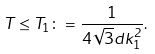Convert formula to latex. <formula><loc_0><loc_0><loc_500><loc_500>T \leq T _ { 1 } \colon = \frac { 1 } { 4 \sqrt { 3 } d k ^ { 2 } _ { 1 } } .</formula> 